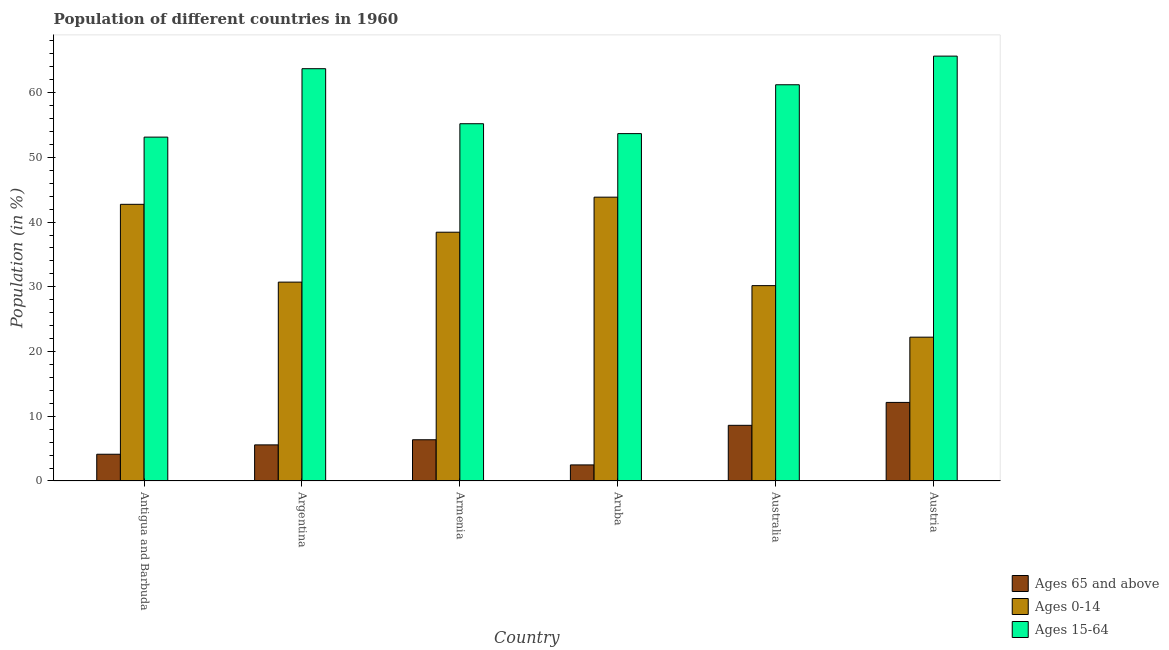How many different coloured bars are there?
Your answer should be compact. 3. Are the number of bars per tick equal to the number of legend labels?
Provide a short and direct response. Yes. Are the number of bars on each tick of the X-axis equal?
Your answer should be compact. Yes. In how many cases, is the number of bars for a given country not equal to the number of legend labels?
Provide a short and direct response. 0. What is the percentage of population within the age-group 15-64 in Armenia?
Your answer should be very brief. 55.2. Across all countries, what is the maximum percentage of population within the age-group 15-64?
Give a very brief answer. 65.64. Across all countries, what is the minimum percentage of population within the age-group 15-64?
Provide a succinct answer. 53.12. In which country was the percentage of population within the age-group 0-14 maximum?
Keep it short and to the point. Aruba. In which country was the percentage of population within the age-group 15-64 minimum?
Your answer should be very brief. Antigua and Barbuda. What is the total percentage of population within the age-group of 65 and above in the graph?
Give a very brief answer. 39.31. What is the difference between the percentage of population within the age-group 0-14 in Armenia and that in Austria?
Provide a succinct answer. 16.21. What is the difference between the percentage of population within the age-group 0-14 in Australia and the percentage of population within the age-group 15-64 in Antigua and Barbuda?
Make the answer very short. -22.94. What is the average percentage of population within the age-group of 65 and above per country?
Keep it short and to the point. 6.55. What is the difference between the percentage of population within the age-group 15-64 and percentage of population within the age-group 0-14 in Antigua and Barbuda?
Offer a very short reply. 10.38. What is the ratio of the percentage of population within the age-group of 65 and above in Armenia to that in Aruba?
Ensure brevity in your answer.  2.56. Is the difference between the percentage of population within the age-group 0-14 in Argentina and Austria greater than the difference between the percentage of population within the age-group of 65 and above in Argentina and Austria?
Make the answer very short. Yes. What is the difference between the highest and the second highest percentage of population within the age-group 15-64?
Your response must be concise. 1.94. What is the difference between the highest and the lowest percentage of population within the age-group of 65 and above?
Your answer should be very brief. 9.66. Is the sum of the percentage of population within the age-group 0-14 in Aruba and Austria greater than the maximum percentage of population within the age-group 15-64 across all countries?
Your answer should be compact. Yes. What does the 3rd bar from the left in Argentina represents?
Offer a very short reply. Ages 15-64. What does the 1st bar from the right in Argentina represents?
Keep it short and to the point. Ages 15-64. Is it the case that in every country, the sum of the percentage of population within the age-group of 65 and above and percentage of population within the age-group 0-14 is greater than the percentage of population within the age-group 15-64?
Offer a terse response. No. How many bars are there?
Provide a succinct answer. 18. Are the values on the major ticks of Y-axis written in scientific E-notation?
Offer a terse response. No. Does the graph contain grids?
Your answer should be compact. No. Where does the legend appear in the graph?
Your answer should be very brief. Bottom right. How are the legend labels stacked?
Ensure brevity in your answer.  Vertical. What is the title of the graph?
Give a very brief answer. Population of different countries in 1960. What is the label or title of the X-axis?
Your answer should be very brief. Country. What is the Population (in %) in Ages 65 and above in Antigua and Barbuda?
Make the answer very short. 4.13. What is the Population (in %) in Ages 0-14 in Antigua and Barbuda?
Make the answer very short. 42.74. What is the Population (in %) in Ages 15-64 in Antigua and Barbuda?
Offer a very short reply. 53.12. What is the Population (in %) in Ages 65 and above in Argentina?
Provide a succinct answer. 5.58. What is the Population (in %) in Ages 0-14 in Argentina?
Your answer should be compact. 30.73. What is the Population (in %) of Ages 15-64 in Argentina?
Your answer should be very brief. 63.7. What is the Population (in %) of Ages 65 and above in Armenia?
Provide a short and direct response. 6.37. What is the Population (in %) of Ages 0-14 in Armenia?
Offer a terse response. 38.43. What is the Population (in %) of Ages 15-64 in Armenia?
Provide a succinct answer. 55.2. What is the Population (in %) in Ages 65 and above in Aruba?
Provide a short and direct response. 2.48. What is the Population (in %) in Ages 0-14 in Aruba?
Provide a short and direct response. 43.85. What is the Population (in %) in Ages 15-64 in Aruba?
Provide a short and direct response. 53.67. What is the Population (in %) in Ages 65 and above in Australia?
Provide a succinct answer. 8.6. What is the Population (in %) in Ages 0-14 in Australia?
Provide a short and direct response. 30.18. What is the Population (in %) of Ages 15-64 in Australia?
Make the answer very short. 61.22. What is the Population (in %) of Ages 65 and above in Austria?
Make the answer very short. 12.14. What is the Population (in %) of Ages 0-14 in Austria?
Your response must be concise. 22.22. What is the Population (in %) of Ages 15-64 in Austria?
Ensure brevity in your answer.  65.64. Across all countries, what is the maximum Population (in %) of Ages 65 and above?
Your answer should be very brief. 12.14. Across all countries, what is the maximum Population (in %) in Ages 0-14?
Make the answer very short. 43.85. Across all countries, what is the maximum Population (in %) of Ages 15-64?
Offer a terse response. 65.64. Across all countries, what is the minimum Population (in %) in Ages 65 and above?
Give a very brief answer. 2.48. Across all countries, what is the minimum Population (in %) of Ages 0-14?
Your answer should be very brief. 22.22. Across all countries, what is the minimum Population (in %) of Ages 15-64?
Give a very brief answer. 53.12. What is the total Population (in %) in Ages 65 and above in the graph?
Give a very brief answer. 39.31. What is the total Population (in %) of Ages 0-14 in the graph?
Give a very brief answer. 208.15. What is the total Population (in %) in Ages 15-64 in the graph?
Provide a short and direct response. 352.54. What is the difference between the Population (in %) in Ages 65 and above in Antigua and Barbuda and that in Argentina?
Offer a very short reply. -1.45. What is the difference between the Population (in %) of Ages 0-14 in Antigua and Barbuda and that in Argentina?
Provide a succinct answer. 12.02. What is the difference between the Population (in %) of Ages 15-64 in Antigua and Barbuda and that in Argentina?
Make the answer very short. -10.57. What is the difference between the Population (in %) of Ages 65 and above in Antigua and Barbuda and that in Armenia?
Ensure brevity in your answer.  -2.24. What is the difference between the Population (in %) in Ages 0-14 in Antigua and Barbuda and that in Armenia?
Keep it short and to the point. 4.31. What is the difference between the Population (in %) of Ages 15-64 in Antigua and Barbuda and that in Armenia?
Your answer should be compact. -2.07. What is the difference between the Population (in %) in Ages 65 and above in Antigua and Barbuda and that in Aruba?
Your response must be concise. 1.65. What is the difference between the Population (in %) in Ages 0-14 in Antigua and Barbuda and that in Aruba?
Your response must be concise. -1.11. What is the difference between the Population (in %) of Ages 15-64 in Antigua and Barbuda and that in Aruba?
Make the answer very short. -0.54. What is the difference between the Population (in %) in Ages 65 and above in Antigua and Barbuda and that in Australia?
Offer a very short reply. -4.47. What is the difference between the Population (in %) of Ages 0-14 in Antigua and Barbuda and that in Australia?
Offer a terse response. 12.56. What is the difference between the Population (in %) in Ages 15-64 in Antigua and Barbuda and that in Australia?
Offer a terse response. -8.09. What is the difference between the Population (in %) in Ages 65 and above in Antigua and Barbuda and that in Austria?
Your answer should be very brief. -8.01. What is the difference between the Population (in %) of Ages 0-14 in Antigua and Barbuda and that in Austria?
Make the answer very short. 20.52. What is the difference between the Population (in %) of Ages 15-64 in Antigua and Barbuda and that in Austria?
Provide a short and direct response. -12.51. What is the difference between the Population (in %) in Ages 65 and above in Argentina and that in Armenia?
Provide a short and direct response. -0.79. What is the difference between the Population (in %) in Ages 0-14 in Argentina and that in Armenia?
Make the answer very short. -7.71. What is the difference between the Population (in %) of Ages 15-64 in Argentina and that in Armenia?
Your answer should be compact. 8.5. What is the difference between the Population (in %) of Ages 65 and above in Argentina and that in Aruba?
Give a very brief answer. 3.09. What is the difference between the Population (in %) of Ages 0-14 in Argentina and that in Aruba?
Give a very brief answer. -13.12. What is the difference between the Population (in %) of Ages 15-64 in Argentina and that in Aruba?
Keep it short and to the point. 10.03. What is the difference between the Population (in %) in Ages 65 and above in Argentina and that in Australia?
Ensure brevity in your answer.  -3.02. What is the difference between the Population (in %) of Ages 0-14 in Argentina and that in Australia?
Ensure brevity in your answer.  0.54. What is the difference between the Population (in %) in Ages 15-64 in Argentina and that in Australia?
Your answer should be very brief. 2.48. What is the difference between the Population (in %) of Ages 65 and above in Argentina and that in Austria?
Provide a short and direct response. -6.56. What is the difference between the Population (in %) of Ages 0-14 in Argentina and that in Austria?
Make the answer very short. 8.5. What is the difference between the Population (in %) of Ages 15-64 in Argentina and that in Austria?
Your answer should be very brief. -1.94. What is the difference between the Population (in %) in Ages 65 and above in Armenia and that in Aruba?
Your response must be concise. 3.89. What is the difference between the Population (in %) in Ages 0-14 in Armenia and that in Aruba?
Keep it short and to the point. -5.41. What is the difference between the Population (in %) of Ages 15-64 in Armenia and that in Aruba?
Offer a very short reply. 1.53. What is the difference between the Population (in %) of Ages 65 and above in Armenia and that in Australia?
Keep it short and to the point. -2.23. What is the difference between the Population (in %) in Ages 0-14 in Armenia and that in Australia?
Your response must be concise. 8.25. What is the difference between the Population (in %) of Ages 15-64 in Armenia and that in Australia?
Ensure brevity in your answer.  -6.02. What is the difference between the Population (in %) in Ages 65 and above in Armenia and that in Austria?
Provide a short and direct response. -5.77. What is the difference between the Population (in %) of Ages 0-14 in Armenia and that in Austria?
Provide a succinct answer. 16.21. What is the difference between the Population (in %) in Ages 15-64 in Armenia and that in Austria?
Your response must be concise. -10.44. What is the difference between the Population (in %) in Ages 65 and above in Aruba and that in Australia?
Give a very brief answer. -6.12. What is the difference between the Population (in %) in Ages 0-14 in Aruba and that in Australia?
Give a very brief answer. 13.67. What is the difference between the Population (in %) in Ages 15-64 in Aruba and that in Australia?
Make the answer very short. -7.55. What is the difference between the Population (in %) of Ages 65 and above in Aruba and that in Austria?
Give a very brief answer. -9.66. What is the difference between the Population (in %) in Ages 0-14 in Aruba and that in Austria?
Ensure brevity in your answer.  21.63. What is the difference between the Population (in %) of Ages 15-64 in Aruba and that in Austria?
Your answer should be compact. -11.97. What is the difference between the Population (in %) in Ages 65 and above in Australia and that in Austria?
Make the answer very short. -3.54. What is the difference between the Population (in %) of Ages 0-14 in Australia and that in Austria?
Provide a short and direct response. 7.96. What is the difference between the Population (in %) of Ages 15-64 in Australia and that in Austria?
Offer a very short reply. -4.42. What is the difference between the Population (in %) in Ages 65 and above in Antigua and Barbuda and the Population (in %) in Ages 0-14 in Argentina?
Your response must be concise. -26.59. What is the difference between the Population (in %) of Ages 65 and above in Antigua and Barbuda and the Population (in %) of Ages 15-64 in Argentina?
Offer a terse response. -59.56. What is the difference between the Population (in %) of Ages 0-14 in Antigua and Barbuda and the Population (in %) of Ages 15-64 in Argentina?
Ensure brevity in your answer.  -20.95. What is the difference between the Population (in %) in Ages 65 and above in Antigua and Barbuda and the Population (in %) in Ages 0-14 in Armenia?
Your answer should be very brief. -34.3. What is the difference between the Population (in %) in Ages 65 and above in Antigua and Barbuda and the Population (in %) in Ages 15-64 in Armenia?
Ensure brevity in your answer.  -51.06. What is the difference between the Population (in %) of Ages 0-14 in Antigua and Barbuda and the Population (in %) of Ages 15-64 in Armenia?
Make the answer very short. -12.45. What is the difference between the Population (in %) in Ages 65 and above in Antigua and Barbuda and the Population (in %) in Ages 0-14 in Aruba?
Offer a terse response. -39.71. What is the difference between the Population (in %) in Ages 65 and above in Antigua and Barbuda and the Population (in %) in Ages 15-64 in Aruba?
Your answer should be compact. -49.53. What is the difference between the Population (in %) of Ages 0-14 in Antigua and Barbuda and the Population (in %) of Ages 15-64 in Aruba?
Your answer should be very brief. -10.92. What is the difference between the Population (in %) of Ages 65 and above in Antigua and Barbuda and the Population (in %) of Ages 0-14 in Australia?
Provide a succinct answer. -26.05. What is the difference between the Population (in %) of Ages 65 and above in Antigua and Barbuda and the Population (in %) of Ages 15-64 in Australia?
Your answer should be compact. -57.08. What is the difference between the Population (in %) of Ages 0-14 in Antigua and Barbuda and the Population (in %) of Ages 15-64 in Australia?
Keep it short and to the point. -18.47. What is the difference between the Population (in %) of Ages 65 and above in Antigua and Barbuda and the Population (in %) of Ages 0-14 in Austria?
Provide a short and direct response. -18.09. What is the difference between the Population (in %) of Ages 65 and above in Antigua and Barbuda and the Population (in %) of Ages 15-64 in Austria?
Your answer should be very brief. -61.51. What is the difference between the Population (in %) of Ages 0-14 in Antigua and Barbuda and the Population (in %) of Ages 15-64 in Austria?
Your answer should be very brief. -22.9. What is the difference between the Population (in %) in Ages 65 and above in Argentina and the Population (in %) in Ages 0-14 in Armenia?
Give a very brief answer. -32.85. What is the difference between the Population (in %) in Ages 65 and above in Argentina and the Population (in %) in Ages 15-64 in Armenia?
Offer a very short reply. -49.62. What is the difference between the Population (in %) of Ages 0-14 in Argentina and the Population (in %) of Ages 15-64 in Armenia?
Your answer should be very brief. -24.47. What is the difference between the Population (in %) of Ages 65 and above in Argentina and the Population (in %) of Ages 0-14 in Aruba?
Your answer should be compact. -38.27. What is the difference between the Population (in %) in Ages 65 and above in Argentina and the Population (in %) in Ages 15-64 in Aruba?
Provide a short and direct response. -48.09. What is the difference between the Population (in %) of Ages 0-14 in Argentina and the Population (in %) of Ages 15-64 in Aruba?
Your answer should be very brief. -22.94. What is the difference between the Population (in %) of Ages 65 and above in Argentina and the Population (in %) of Ages 0-14 in Australia?
Your answer should be very brief. -24.6. What is the difference between the Population (in %) of Ages 65 and above in Argentina and the Population (in %) of Ages 15-64 in Australia?
Keep it short and to the point. -55.64. What is the difference between the Population (in %) of Ages 0-14 in Argentina and the Population (in %) of Ages 15-64 in Australia?
Keep it short and to the point. -30.49. What is the difference between the Population (in %) of Ages 65 and above in Argentina and the Population (in %) of Ages 0-14 in Austria?
Offer a terse response. -16.64. What is the difference between the Population (in %) in Ages 65 and above in Argentina and the Population (in %) in Ages 15-64 in Austria?
Provide a short and direct response. -60.06. What is the difference between the Population (in %) of Ages 0-14 in Argentina and the Population (in %) of Ages 15-64 in Austria?
Provide a short and direct response. -34.91. What is the difference between the Population (in %) of Ages 65 and above in Armenia and the Population (in %) of Ages 0-14 in Aruba?
Keep it short and to the point. -37.48. What is the difference between the Population (in %) in Ages 65 and above in Armenia and the Population (in %) in Ages 15-64 in Aruba?
Your response must be concise. -47.3. What is the difference between the Population (in %) in Ages 0-14 in Armenia and the Population (in %) in Ages 15-64 in Aruba?
Make the answer very short. -15.23. What is the difference between the Population (in %) of Ages 65 and above in Armenia and the Population (in %) of Ages 0-14 in Australia?
Provide a short and direct response. -23.81. What is the difference between the Population (in %) in Ages 65 and above in Armenia and the Population (in %) in Ages 15-64 in Australia?
Your answer should be compact. -54.84. What is the difference between the Population (in %) of Ages 0-14 in Armenia and the Population (in %) of Ages 15-64 in Australia?
Give a very brief answer. -22.78. What is the difference between the Population (in %) in Ages 65 and above in Armenia and the Population (in %) in Ages 0-14 in Austria?
Provide a short and direct response. -15.85. What is the difference between the Population (in %) in Ages 65 and above in Armenia and the Population (in %) in Ages 15-64 in Austria?
Your answer should be compact. -59.27. What is the difference between the Population (in %) of Ages 0-14 in Armenia and the Population (in %) of Ages 15-64 in Austria?
Your answer should be very brief. -27.21. What is the difference between the Population (in %) of Ages 65 and above in Aruba and the Population (in %) of Ages 0-14 in Australia?
Ensure brevity in your answer.  -27.7. What is the difference between the Population (in %) in Ages 65 and above in Aruba and the Population (in %) in Ages 15-64 in Australia?
Ensure brevity in your answer.  -58.73. What is the difference between the Population (in %) in Ages 0-14 in Aruba and the Population (in %) in Ages 15-64 in Australia?
Offer a terse response. -17.37. What is the difference between the Population (in %) of Ages 65 and above in Aruba and the Population (in %) of Ages 0-14 in Austria?
Give a very brief answer. -19.74. What is the difference between the Population (in %) in Ages 65 and above in Aruba and the Population (in %) in Ages 15-64 in Austria?
Your response must be concise. -63.15. What is the difference between the Population (in %) of Ages 0-14 in Aruba and the Population (in %) of Ages 15-64 in Austria?
Your response must be concise. -21.79. What is the difference between the Population (in %) of Ages 65 and above in Australia and the Population (in %) of Ages 0-14 in Austria?
Ensure brevity in your answer.  -13.62. What is the difference between the Population (in %) of Ages 65 and above in Australia and the Population (in %) of Ages 15-64 in Austria?
Offer a very short reply. -57.04. What is the difference between the Population (in %) in Ages 0-14 in Australia and the Population (in %) in Ages 15-64 in Austria?
Offer a very short reply. -35.46. What is the average Population (in %) of Ages 65 and above per country?
Your answer should be compact. 6.55. What is the average Population (in %) of Ages 0-14 per country?
Your answer should be compact. 34.69. What is the average Population (in %) in Ages 15-64 per country?
Provide a succinct answer. 58.76. What is the difference between the Population (in %) of Ages 65 and above and Population (in %) of Ages 0-14 in Antigua and Barbuda?
Offer a very short reply. -38.61. What is the difference between the Population (in %) in Ages 65 and above and Population (in %) in Ages 15-64 in Antigua and Barbuda?
Provide a short and direct response. -48.99. What is the difference between the Population (in %) of Ages 0-14 and Population (in %) of Ages 15-64 in Antigua and Barbuda?
Make the answer very short. -10.38. What is the difference between the Population (in %) in Ages 65 and above and Population (in %) in Ages 0-14 in Argentina?
Give a very brief answer. -25.15. What is the difference between the Population (in %) in Ages 65 and above and Population (in %) in Ages 15-64 in Argentina?
Make the answer very short. -58.12. What is the difference between the Population (in %) in Ages 0-14 and Population (in %) in Ages 15-64 in Argentina?
Provide a short and direct response. -32.97. What is the difference between the Population (in %) in Ages 65 and above and Population (in %) in Ages 0-14 in Armenia?
Make the answer very short. -32.06. What is the difference between the Population (in %) in Ages 65 and above and Population (in %) in Ages 15-64 in Armenia?
Ensure brevity in your answer.  -48.82. What is the difference between the Population (in %) in Ages 0-14 and Population (in %) in Ages 15-64 in Armenia?
Give a very brief answer. -16.76. What is the difference between the Population (in %) in Ages 65 and above and Population (in %) in Ages 0-14 in Aruba?
Offer a terse response. -41.36. What is the difference between the Population (in %) in Ages 65 and above and Population (in %) in Ages 15-64 in Aruba?
Make the answer very short. -51.18. What is the difference between the Population (in %) in Ages 0-14 and Population (in %) in Ages 15-64 in Aruba?
Offer a terse response. -9.82. What is the difference between the Population (in %) in Ages 65 and above and Population (in %) in Ages 0-14 in Australia?
Offer a very short reply. -21.58. What is the difference between the Population (in %) in Ages 65 and above and Population (in %) in Ages 15-64 in Australia?
Ensure brevity in your answer.  -52.61. What is the difference between the Population (in %) in Ages 0-14 and Population (in %) in Ages 15-64 in Australia?
Your response must be concise. -31.03. What is the difference between the Population (in %) in Ages 65 and above and Population (in %) in Ages 0-14 in Austria?
Your response must be concise. -10.08. What is the difference between the Population (in %) in Ages 65 and above and Population (in %) in Ages 15-64 in Austria?
Offer a terse response. -53.5. What is the difference between the Population (in %) in Ages 0-14 and Population (in %) in Ages 15-64 in Austria?
Your answer should be compact. -43.42. What is the ratio of the Population (in %) of Ages 65 and above in Antigua and Barbuda to that in Argentina?
Your answer should be compact. 0.74. What is the ratio of the Population (in %) of Ages 0-14 in Antigua and Barbuda to that in Argentina?
Give a very brief answer. 1.39. What is the ratio of the Population (in %) in Ages 15-64 in Antigua and Barbuda to that in Argentina?
Your answer should be compact. 0.83. What is the ratio of the Population (in %) of Ages 65 and above in Antigua and Barbuda to that in Armenia?
Ensure brevity in your answer.  0.65. What is the ratio of the Population (in %) in Ages 0-14 in Antigua and Barbuda to that in Armenia?
Your answer should be compact. 1.11. What is the ratio of the Population (in %) in Ages 15-64 in Antigua and Barbuda to that in Armenia?
Keep it short and to the point. 0.96. What is the ratio of the Population (in %) of Ages 65 and above in Antigua and Barbuda to that in Aruba?
Your answer should be very brief. 1.66. What is the ratio of the Population (in %) in Ages 0-14 in Antigua and Barbuda to that in Aruba?
Your answer should be compact. 0.97. What is the ratio of the Population (in %) in Ages 65 and above in Antigua and Barbuda to that in Australia?
Ensure brevity in your answer.  0.48. What is the ratio of the Population (in %) of Ages 0-14 in Antigua and Barbuda to that in Australia?
Offer a very short reply. 1.42. What is the ratio of the Population (in %) in Ages 15-64 in Antigua and Barbuda to that in Australia?
Make the answer very short. 0.87. What is the ratio of the Population (in %) of Ages 65 and above in Antigua and Barbuda to that in Austria?
Ensure brevity in your answer.  0.34. What is the ratio of the Population (in %) in Ages 0-14 in Antigua and Barbuda to that in Austria?
Your response must be concise. 1.92. What is the ratio of the Population (in %) of Ages 15-64 in Antigua and Barbuda to that in Austria?
Ensure brevity in your answer.  0.81. What is the ratio of the Population (in %) in Ages 65 and above in Argentina to that in Armenia?
Provide a succinct answer. 0.88. What is the ratio of the Population (in %) in Ages 0-14 in Argentina to that in Armenia?
Make the answer very short. 0.8. What is the ratio of the Population (in %) of Ages 15-64 in Argentina to that in Armenia?
Your answer should be very brief. 1.15. What is the ratio of the Population (in %) of Ages 65 and above in Argentina to that in Aruba?
Your answer should be very brief. 2.25. What is the ratio of the Population (in %) of Ages 0-14 in Argentina to that in Aruba?
Offer a very short reply. 0.7. What is the ratio of the Population (in %) of Ages 15-64 in Argentina to that in Aruba?
Give a very brief answer. 1.19. What is the ratio of the Population (in %) of Ages 65 and above in Argentina to that in Australia?
Offer a very short reply. 0.65. What is the ratio of the Population (in %) of Ages 15-64 in Argentina to that in Australia?
Ensure brevity in your answer.  1.04. What is the ratio of the Population (in %) of Ages 65 and above in Argentina to that in Austria?
Provide a succinct answer. 0.46. What is the ratio of the Population (in %) in Ages 0-14 in Argentina to that in Austria?
Your answer should be compact. 1.38. What is the ratio of the Population (in %) of Ages 15-64 in Argentina to that in Austria?
Your answer should be very brief. 0.97. What is the ratio of the Population (in %) in Ages 65 and above in Armenia to that in Aruba?
Your answer should be very brief. 2.56. What is the ratio of the Population (in %) in Ages 0-14 in Armenia to that in Aruba?
Offer a terse response. 0.88. What is the ratio of the Population (in %) in Ages 15-64 in Armenia to that in Aruba?
Keep it short and to the point. 1.03. What is the ratio of the Population (in %) of Ages 65 and above in Armenia to that in Australia?
Keep it short and to the point. 0.74. What is the ratio of the Population (in %) of Ages 0-14 in Armenia to that in Australia?
Give a very brief answer. 1.27. What is the ratio of the Population (in %) of Ages 15-64 in Armenia to that in Australia?
Ensure brevity in your answer.  0.9. What is the ratio of the Population (in %) of Ages 65 and above in Armenia to that in Austria?
Make the answer very short. 0.52. What is the ratio of the Population (in %) of Ages 0-14 in Armenia to that in Austria?
Keep it short and to the point. 1.73. What is the ratio of the Population (in %) in Ages 15-64 in Armenia to that in Austria?
Keep it short and to the point. 0.84. What is the ratio of the Population (in %) of Ages 65 and above in Aruba to that in Australia?
Provide a short and direct response. 0.29. What is the ratio of the Population (in %) of Ages 0-14 in Aruba to that in Australia?
Keep it short and to the point. 1.45. What is the ratio of the Population (in %) of Ages 15-64 in Aruba to that in Australia?
Provide a short and direct response. 0.88. What is the ratio of the Population (in %) of Ages 65 and above in Aruba to that in Austria?
Offer a very short reply. 0.2. What is the ratio of the Population (in %) in Ages 0-14 in Aruba to that in Austria?
Keep it short and to the point. 1.97. What is the ratio of the Population (in %) in Ages 15-64 in Aruba to that in Austria?
Offer a terse response. 0.82. What is the ratio of the Population (in %) of Ages 65 and above in Australia to that in Austria?
Offer a terse response. 0.71. What is the ratio of the Population (in %) in Ages 0-14 in Australia to that in Austria?
Keep it short and to the point. 1.36. What is the ratio of the Population (in %) of Ages 15-64 in Australia to that in Austria?
Ensure brevity in your answer.  0.93. What is the difference between the highest and the second highest Population (in %) of Ages 65 and above?
Provide a succinct answer. 3.54. What is the difference between the highest and the second highest Population (in %) of Ages 0-14?
Make the answer very short. 1.11. What is the difference between the highest and the second highest Population (in %) of Ages 15-64?
Offer a terse response. 1.94. What is the difference between the highest and the lowest Population (in %) of Ages 65 and above?
Provide a succinct answer. 9.66. What is the difference between the highest and the lowest Population (in %) of Ages 0-14?
Your answer should be very brief. 21.63. What is the difference between the highest and the lowest Population (in %) of Ages 15-64?
Give a very brief answer. 12.51. 